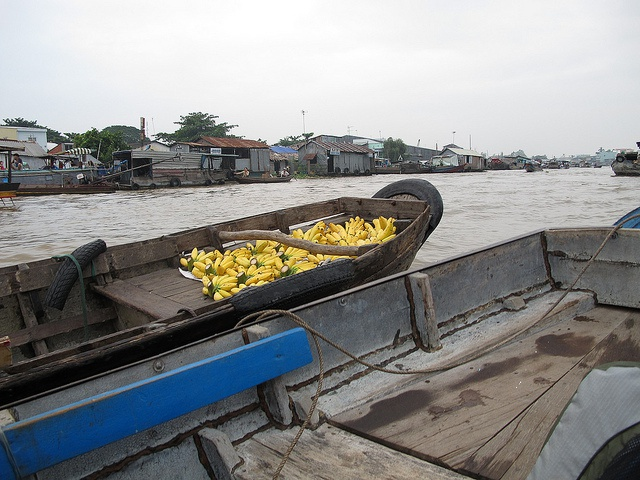Describe the objects in this image and their specific colors. I can see boat in lavender, gray, black, and darkgray tones, boat in lavender, black, and gray tones, banana in lavender, khaki, olive, tan, and orange tones, banana in lavender, khaki, and olive tones, and boat in lavender, gray, black, darkgray, and lightgray tones in this image. 